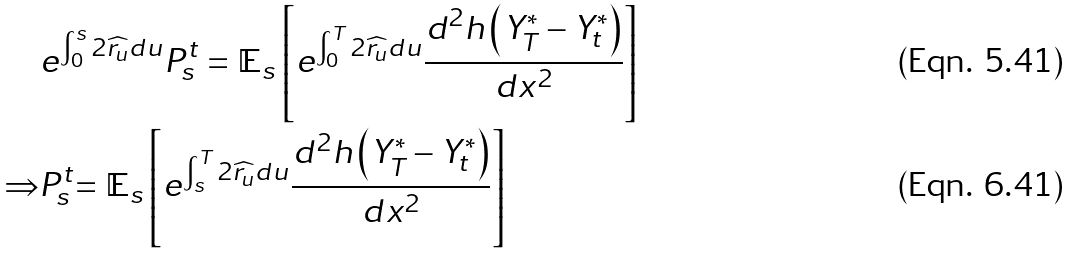<formula> <loc_0><loc_0><loc_500><loc_500>& e ^ { \int _ { 0 } ^ { s } 2 \widehat { r _ { u } } d u } P _ { s } ^ { t } = \mathbb { E } _ { s } \left [ e ^ { \int _ { 0 } ^ { T } 2 \widehat { r _ { u } } d u } \frac { d ^ { 2 } h \left ( Y _ { T } ^ { * } - Y _ { t } ^ { * } \right ) } { d x ^ { 2 } } \right ] \\ \Rightarrow & P _ { s } ^ { t } \mathbb { = E } _ { s } \left [ e ^ { \int _ { s } ^ { T } 2 \widehat { r _ { u } } d u } \frac { d ^ { 2 } h \left ( Y _ { T } ^ { * } - Y _ { t } ^ { * } \right ) } { d x ^ { 2 } } \right ]</formula> 